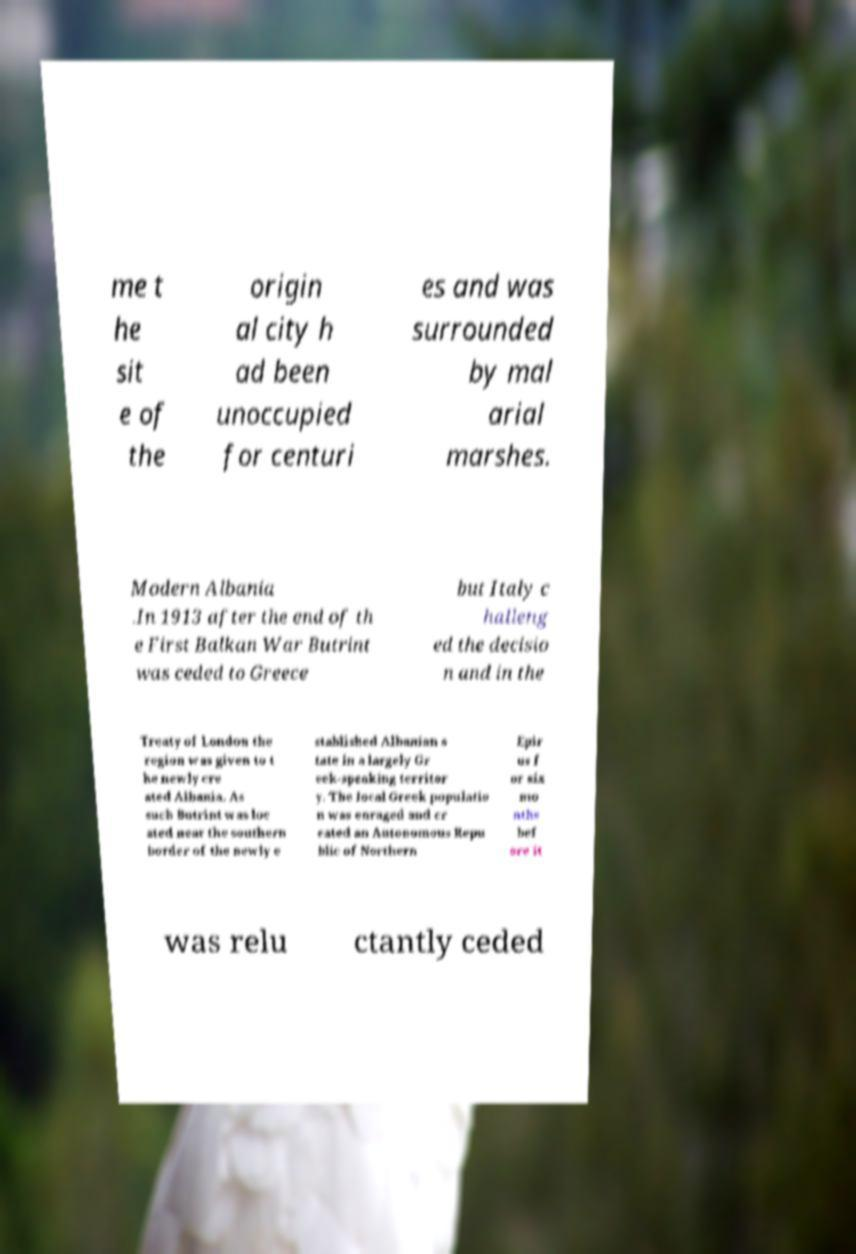For documentation purposes, I need the text within this image transcribed. Could you provide that? me t he sit e of the origin al city h ad been unoccupied for centuri es and was surrounded by mal arial marshes. Modern Albania .In 1913 after the end of th e First Balkan War Butrint was ceded to Greece but Italy c halleng ed the decisio n and in the Treaty of London the region was given to t he newly cre ated Albania. As such Butrint was loc ated near the southern border of the newly e stablished Albanian s tate in a largely Gr eek-speaking territor y. The local Greek populatio n was enraged and cr eated an Autonomous Repu blic of Northern Epir us f or six mo nths bef ore it was relu ctantly ceded 